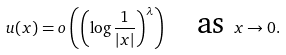Convert formula to latex. <formula><loc_0><loc_0><loc_500><loc_500>u ( x ) = o \left ( \left ( \log \frac { 1 } { | x | } \right ) ^ { \lambda } \right ) \quad \text {as } x \to 0 .</formula> 